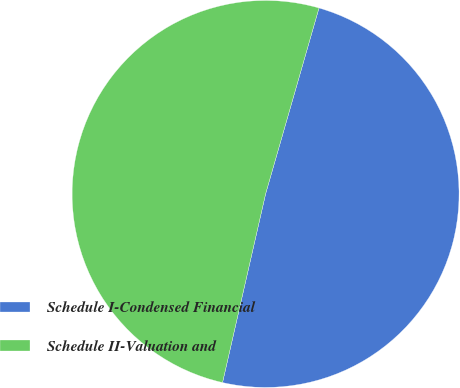Convert chart to OTSL. <chart><loc_0><loc_0><loc_500><loc_500><pie_chart><fcel>Schedule I-Condensed Financial<fcel>Schedule II-Valuation and<nl><fcel>49.12%<fcel>50.88%<nl></chart> 